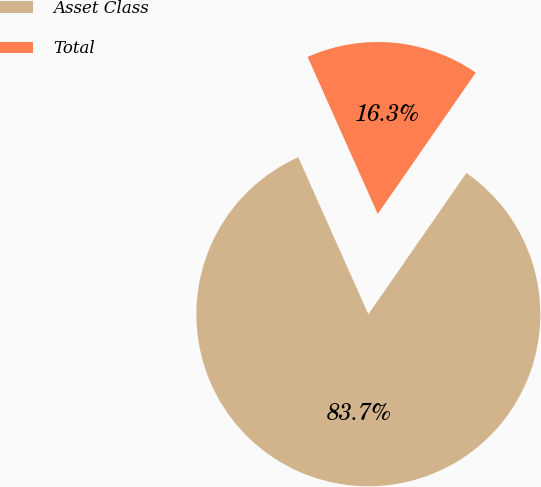Convert chart to OTSL. <chart><loc_0><loc_0><loc_500><loc_500><pie_chart><fcel>Asset Class<fcel>Total<nl><fcel>83.67%<fcel>16.33%<nl></chart> 